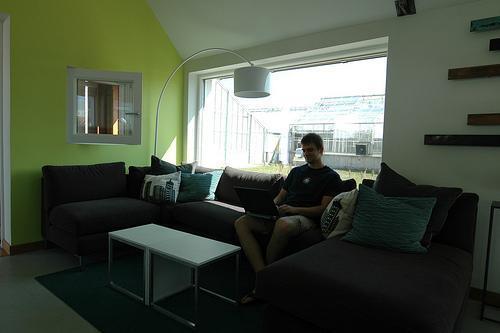How many people are in this picture?
Give a very brief answer. 1. 